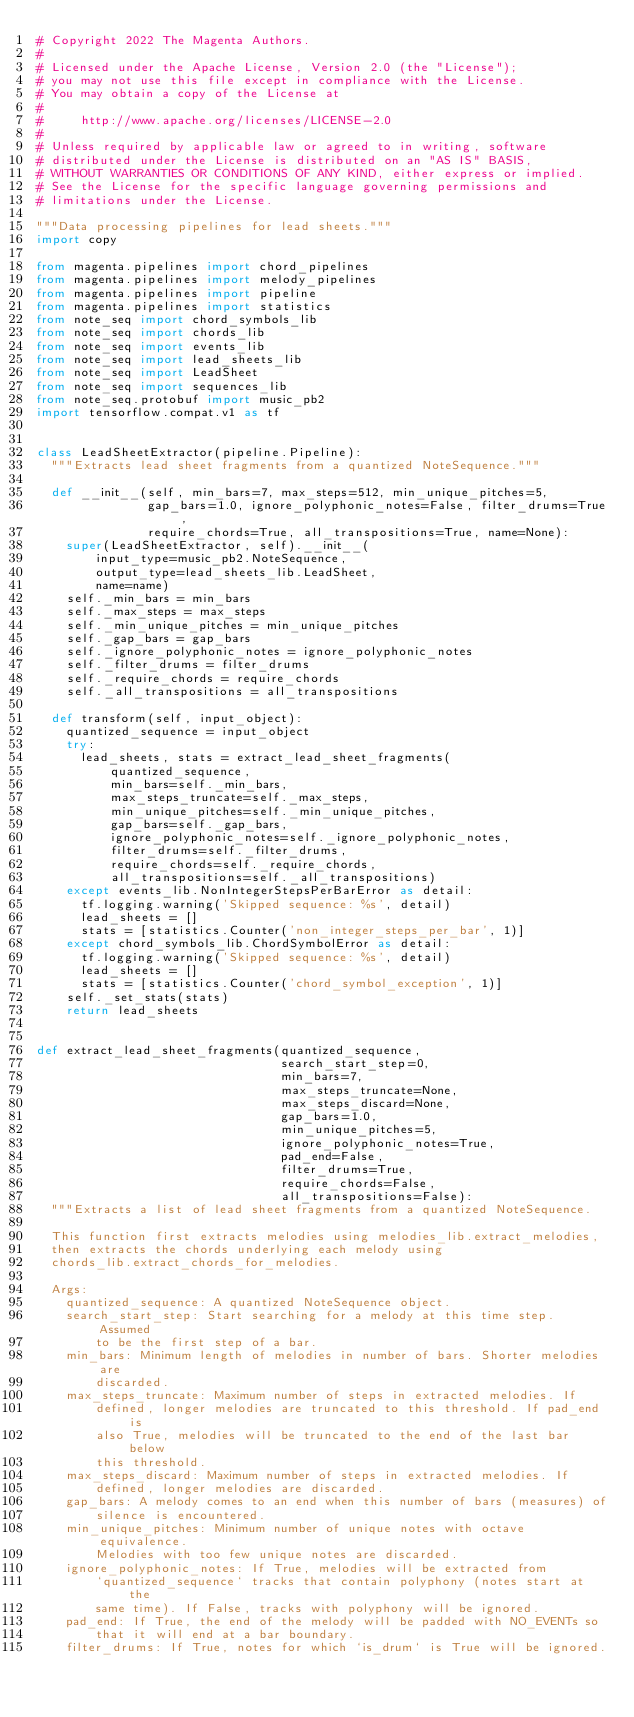<code> <loc_0><loc_0><loc_500><loc_500><_Python_># Copyright 2022 The Magenta Authors.
#
# Licensed under the Apache License, Version 2.0 (the "License");
# you may not use this file except in compliance with the License.
# You may obtain a copy of the License at
#
#     http://www.apache.org/licenses/LICENSE-2.0
#
# Unless required by applicable law or agreed to in writing, software
# distributed under the License is distributed on an "AS IS" BASIS,
# WITHOUT WARRANTIES OR CONDITIONS OF ANY KIND, either express or implied.
# See the License for the specific language governing permissions and
# limitations under the License.

"""Data processing pipelines for lead sheets."""
import copy

from magenta.pipelines import chord_pipelines
from magenta.pipelines import melody_pipelines
from magenta.pipelines import pipeline
from magenta.pipelines import statistics
from note_seq import chord_symbols_lib
from note_seq import chords_lib
from note_seq import events_lib
from note_seq import lead_sheets_lib
from note_seq import LeadSheet
from note_seq import sequences_lib
from note_seq.protobuf import music_pb2
import tensorflow.compat.v1 as tf


class LeadSheetExtractor(pipeline.Pipeline):
  """Extracts lead sheet fragments from a quantized NoteSequence."""

  def __init__(self, min_bars=7, max_steps=512, min_unique_pitches=5,
               gap_bars=1.0, ignore_polyphonic_notes=False, filter_drums=True,
               require_chords=True, all_transpositions=True, name=None):
    super(LeadSheetExtractor, self).__init__(
        input_type=music_pb2.NoteSequence,
        output_type=lead_sheets_lib.LeadSheet,
        name=name)
    self._min_bars = min_bars
    self._max_steps = max_steps
    self._min_unique_pitches = min_unique_pitches
    self._gap_bars = gap_bars
    self._ignore_polyphonic_notes = ignore_polyphonic_notes
    self._filter_drums = filter_drums
    self._require_chords = require_chords
    self._all_transpositions = all_transpositions

  def transform(self, input_object):
    quantized_sequence = input_object
    try:
      lead_sheets, stats = extract_lead_sheet_fragments(
          quantized_sequence,
          min_bars=self._min_bars,
          max_steps_truncate=self._max_steps,
          min_unique_pitches=self._min_unique_pitches,
          gap_bars=self._gap_bars,
          ignore_polyphonic_notes=self._ignore_polyphonic_notes,
          filter_drums=self._filter_drums,
          require_chords=self._require_chords,
          all_transpositions=self._all_transpositions)
    except events_lib.NonIntegerStepsPerBarError as detail:
      tf.logging.warning('Skipped sequence: %s', detail)
      lead_sheets = []
      stats = [statistics.Counter('non_integer_steps_per_bar', 1)]
    except chord_symbols_lib.ChordSymbolError as detail:
      tf.logging.warning('Skipped sequence: %s', detail)
      lead_sheets = []
      stats = [statistics.Counter('chord_symbol_exception', 1)]
    self._set_stats(stats)
    return lead_sheets


def extract_lead_sheet_fragments(quantized_sequence,
                                 search_start_step=0,
                                 min_bars=7,
                                 max_steps_truncate=None,
                                 max_steps_discard=None,
                                 gap_bars=1.0,
                                 min_unique_pitches=5,
                                 ignore_polyphonic_notes=True,
                                 pad_end=False,
                                 filter_drums=True,
                                 require_chords=False,
                                 all_transpositions=False):
  """Extracts a list of lead sheet fragments from a quantized NoteSequence.

  This function first extracts melodies using melodies_lib.extract_melodies,
  then extracts the chords underlying each melody using
  chords_lib.extract_chords_for_melodies.

  Args:
    quantized_sequence: A quantized NoteSequence object.
    search_start_step: Start searching for a melody at this time step. Assumed
        to be the first step of a bar.
    min_bars: Minimum length of melodies in number of bars. Shorter melodies are
        discarded.
    max_steps_truncate: Maximum number of steps in extracted melodies. If
        defined, longer melodies are truncated to this threshold. If pad_end is
        also True, melodies will be truncated to the end of the last bar below
        this threshold.
    max_steps_discard: Maximum number of steps in extracted melodies. If
        defined, longer melodies are discarded.
    gap_bars: A melody comes to an end when this number of bars (measures) of
        silence is encountered.
    min_unique_pitches: Minimum number of unique notes with octave equivalence.
        Melodies with too few unique notes are discarded.
    ignore_polyphonic_notes: If True, melodies will be extracted from
        `quantized_sequence` tracks that contain polyphony (notes start at the
        same time). If False, tracks with polyphony will be ignored.
    pad_end: If True, the end of the melody will be padded with NO_EVENTs so
        that it will end at a bar boundary.
    filter_drums: If True, notes for which `is_drum` is True will be ignored.</code> 